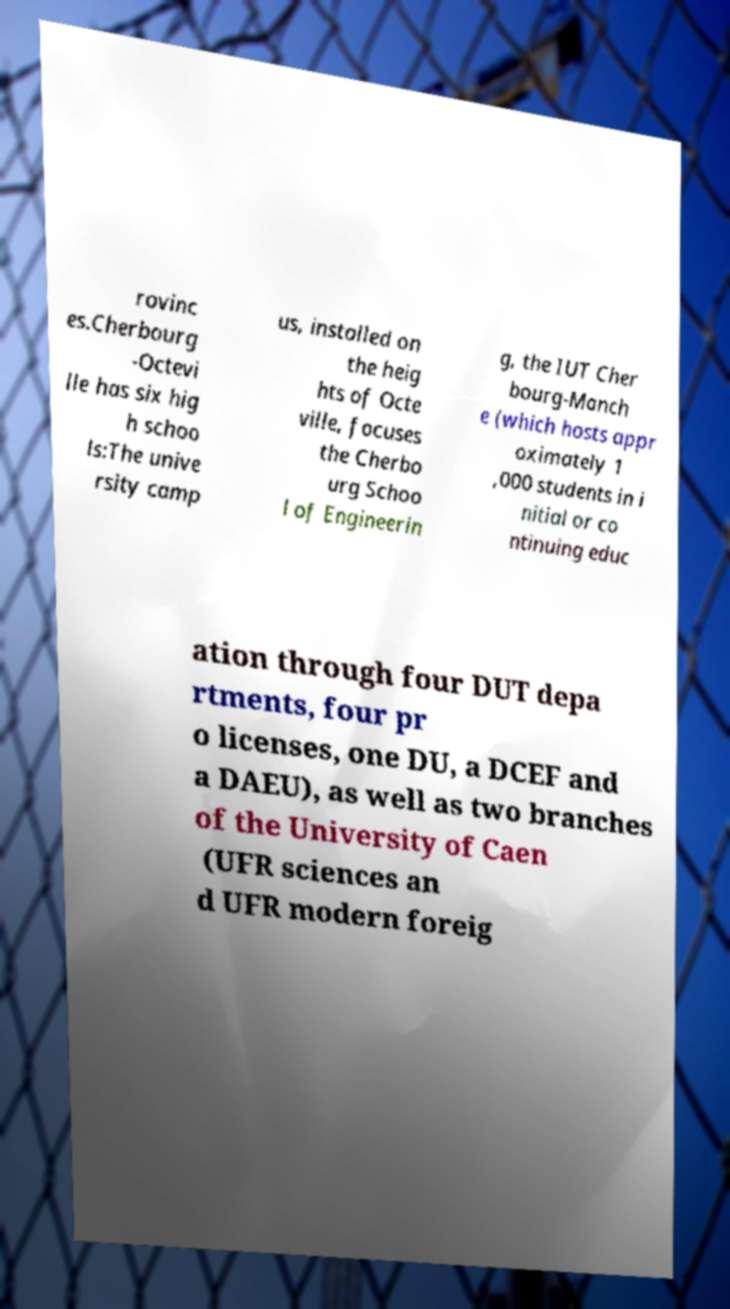Can you read and provide the text displayed in the image?This photo seems to have some interesting text. Can you extract and type it out for me? rovinc es.Cherbourg -Octevi lle has six hig h schoo ls:The unive rsity camp us, installed on the heig hts of Octe ville, focuses the Cherbo urg Schoo l of Engineerin g, the IUT Cher bourg-Manch e (which hosts appr oximately 1 ,000 students in i nitial or co ntinuing educ ation through four DUT depa rtments, four pr o licenses, one DU, a DCEF and a DAEU), as well as two branches of the University of Caen (UFR sciences an d UFR modern foreig 